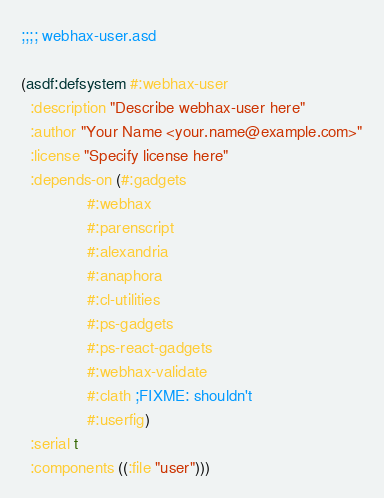<code> <loc_0><loc_0><loc_500><loc_500><_Lisp_>;;;; webhax-user.asd

(asdf:defsystem #:webhax-user
  :description "Describe webhax-user here"
  :author "Your Name <your.name@example.com>"
  :license "Specify license here"
  :depends-on (#:gadgets
               #:webhax
               #:parenscript
               #:alexandria
               #:anaphora
               #:cl-utilities
               #:ps-gadgets
               #:ps-react-gadgets
               #:webhax-validate
               #:clath ;FIXME: shouldn't
               #:userfig)
  :serial t
  :components ((:file "user")))

</code> 